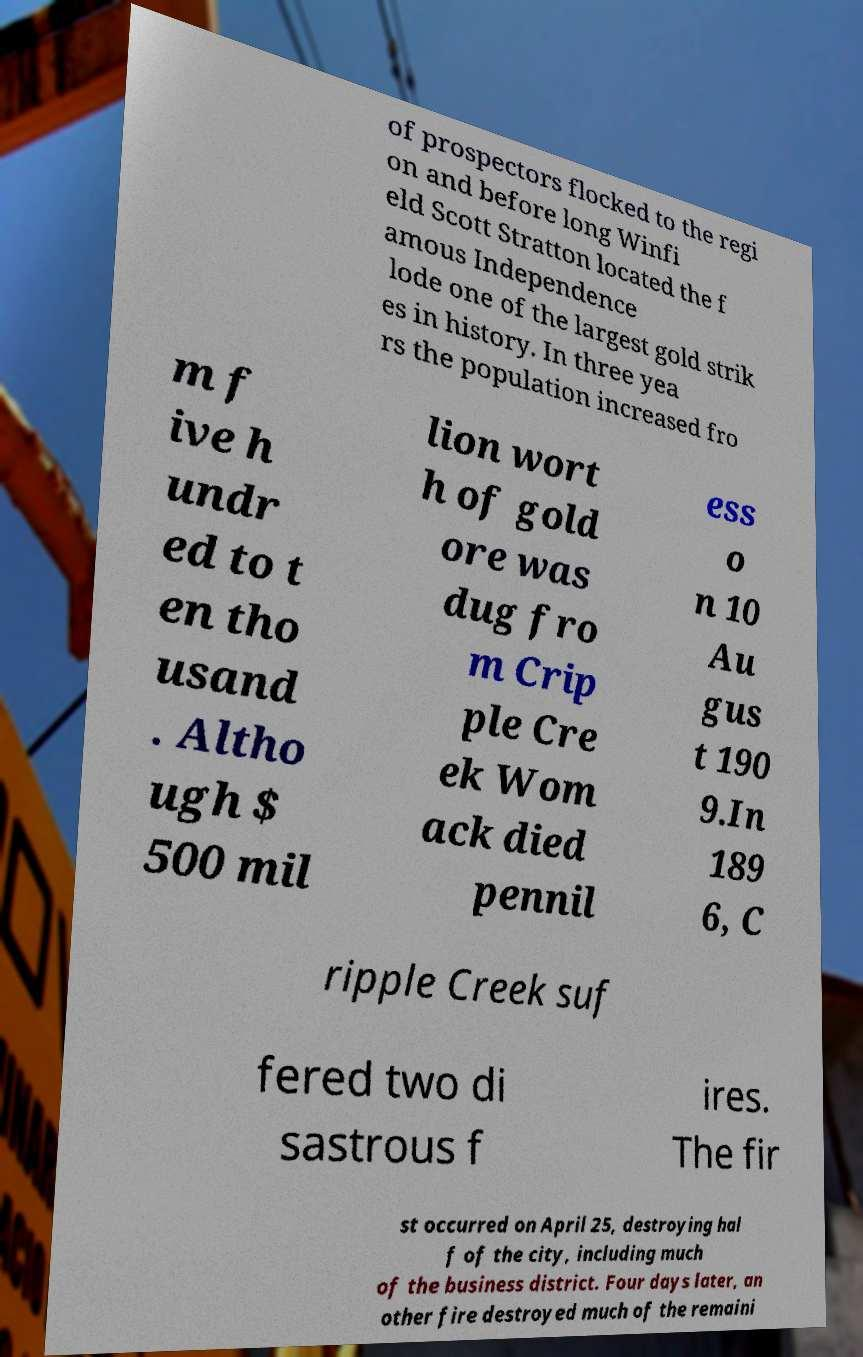What messages or text are displayed in this image? I need them in a readable, typed format. of prospectors flocked to the regi on and before long Winfi eld Scott Stratton located the f amous Independence lode one of the largest gold strik es in history. In three yea rs the population increased fro m f ive h undr ed to t en tho usand . Altho ugh $ 500 mil lion wort h of gold ore was dug fro m Crip ple Cre ek Wom ack died pennil ess o n 10 Au gus t 190 9.In 189 6, C ripple Creek suf fered two di sastrous f ires. The fir st occurred on April 25, destroying hal f of the city, including much of the business district. Four days later, an other fire destroyed much of the remaini 